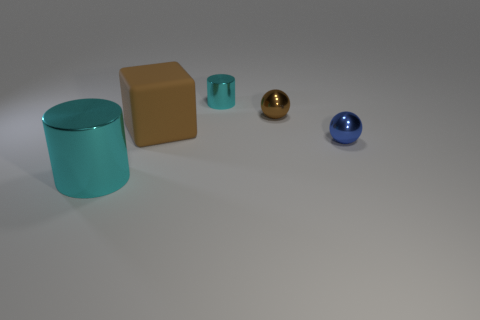Is the color of the small ball behind the large brown cube the same as the matte cube?
Give a very brief answer. Yes. How many blocks are either small yellow matte objects or tiny brown things?
Your answer should be compact. 0. What number of cylinders are right of the metal cylinder on the left side of the cyan metal cylinder that is behind the big brown matte thing?
Offer a very short reply. 1. Are there more small blue metallic spheres than big yellow metal cylinders?
Ensure brevity in your answer.  Yes. Do the blue metallic object and the matte cube have the same size?
Provide a succinct answer. No. What number of objects are small rubber cylinders or tiny shiny balls?
Your answer should be compact. 2. What shape is the cyan object behind the cyan object in front of the large object on the right side of the big metallic cylinder?
Provide a succinct answer. Cylinder. Does the cyan thing that is left of the tiny cylinder have the same material as the brown thing to the left of the small cyan cylinder?
Your response must be concise. No. Do the big object left of the block and the brown object right of the tiny cyan thing have the same shape?
Keep it short and to the point. No. Are there fewer cyan metal objects behind the large cyan metallic thing than metal things that are on the left side of the blue sphere?
Offer a terse response. Yes. 